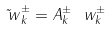<formula> <loc_0><loc_0><loc_500><loc_500>\tilde { \ w } _ { k } ^ { \pm } = A _ { k } ^ { \pm } \ w _ { k } ^ { \pm }</formula> 